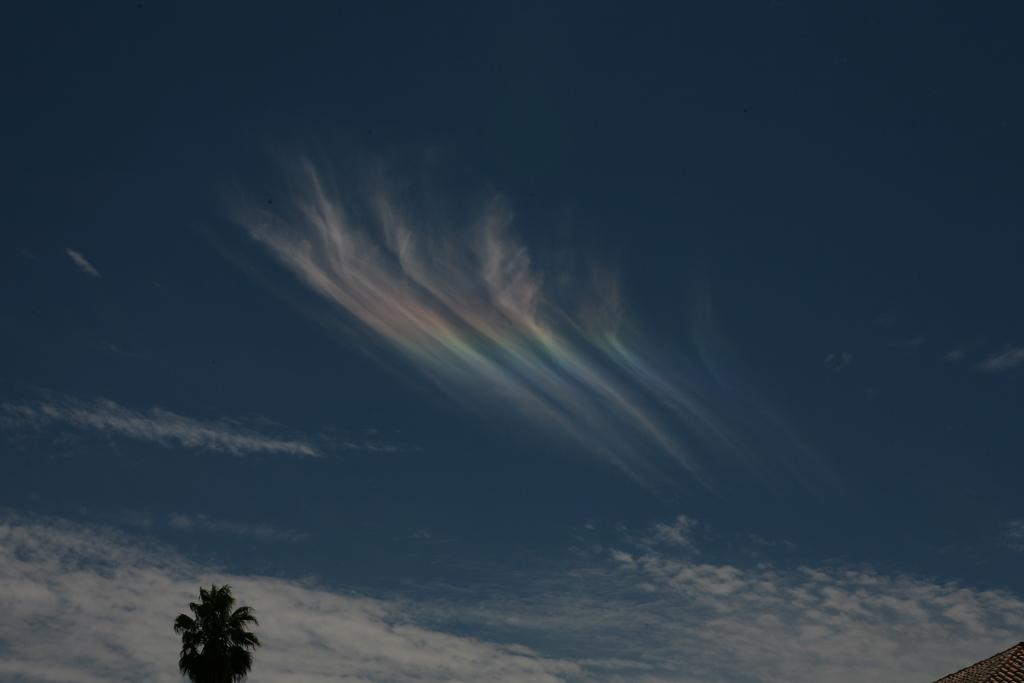What type of plant can be seen in the image? There is a tree in the image. What part of the natural environment is visible in the image? The sky is visible in the background of the image. What type of club can be seen in the image? There is no club present in the image; it features a tree and the sky. What design elements are present in the image? The image does not contain any design elements, as it is a photograph of a tree and the sky. 